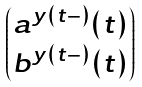<formula> <loc_0><loc_0><loc_500><loc_500>\begin{pmatrix} a ^ { y ( t - ) } ( t ) \\ b ^ { y ( t - ) } ( t ) \end{pmatrix}</formula> 